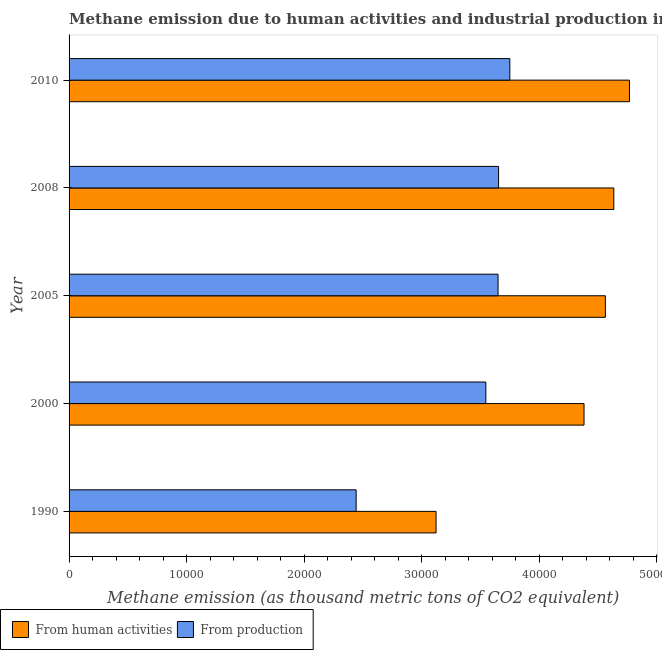Are the number of bars per tick equal to the number of legend labels?
Make the answer very short. Yes. How many bars are there on the 1st tick from the top?
Offer a terse response. 2. How many bars are there on the 3rd tick from the bottom?
Provide a succinct answer. 2. In how many cases, is the number of bars for a given year not equal to the number of legend labels?
Your answer should be very brief. 0. What is the amount of emissions generated from industries in 2000?
Provide a succinct answer. 3.54e+04. Across all years, what is the maximum amount of emissions from human activities?
Offer a terse response. 4.77e+04. Across all years, what is the minimum amount of emissions generated from industries?
Make the answer very short. 2.44e+04. In which year was the amount of emissions from human activities minimum?
Ensure brevity in your answer.  1990. What is the total amount of emissions from human activities in the graph?
Make the answer very short. 2.15e+05. What is the difference between the amount of emissions from human activities in 1990 and that in 2000?
Offer a terse response. -1.26e+04. What is the difference between the amount of emissions generated from industries in 2000 and the amount of emissions from human activities in 2010?
Make the answer very short. -1.22e+04. What is the average amount of emissions from human activities per year?
Your answer should be compact. 4.29e+04. In the year 1990, what is the difference between the amount of emissions from human activities and amount of emissions generated from industries?
Offer a terse response. 6797.8. In how many years, is the amount of emissions from human activities greater than 20000 thousand metric tons?
Give a very brief answer. 5. Is the amount of emissions generated from industries in 2000 less than that in 2008?
Provide a succinct answer. Yes. What is the difference between the highest and the second highest amount of emissions generated from industries?
Your response must be concise. 954.9. What is the difference between the highest and the lowest amount of emissions generated from industries?
Give a very brief answer. 1.31e+04. In how many years, is the amount of emissions generated from industries greater than the average amount of emissions generated from industries taken over all years?
Offer a terse response. 4. What does the 2nd bar from the top in 2010 represents?
Offer a terse response. From human activities. What does the 2nd bar from the bottom in 2005 represents?
Give a very brief answer. From production. How many bars are there?
Your answer should be compact. 10. Are all the bars in the graph horizontal?
Offer a very short reply. Yes. How many years are there in the graph?
Keep it short and to the point. 5. Are the values on the major ticks of X-axis written in scientific E-notation?
Offer a very short reply. No. Does the graph contain any zero values?
Your answer should be compact. No. Where does the legend appear in the graph?
Offer a very short reply. Bottom left. What is the title of the graph?
Keep it short and to the point. Methane emission due to human activities and industrial production in Algeria. What is the label or title of the X-axis?
Your answer should be compact. Methane emission (as thousand metric tons of CO2 equivalent). What is the Methane emission (as thousand metric tons of CO2 equivalent) of From human activities in 1990?
Give a very brief answer. 3.12e+04. What is the Methane emission (as thousand metric tons of CO2 equivalent) of From production in 1990?
Offer a very short reply. 2.44e+04. What is the Methane emission (as thousand metric tons of CO2 equivalent) in From human activities in 2000?
Give a very brief answer. 4.38e+04. What is the Methane emission (as thousand metric tons of CO2 equivalent) of From production in 2000?
Give a very brief answer. 3.54e+04. What is the Methane emission (as thousand metric tons of CO2 equivalent) of From human activities in 2005?
Your answer should be compact. 4.56e+04. What is the Methane emission (as thousand metric tons of CO2 equivalent) of From production in 2005?
Provide a succinct answer. 3.65e+04. What is the Methane emission (as thousand metric tons of CO2 equivalent) of From human activities in 2008?
Provide a succinct answer. 4.63e+04. What is the Methane emission (as thousand metric tons of CO2 equivalent) in From production in 2008?
Provide a succinct answer. 3.65e+04. What is the Methane emission (as thousand metric tons of CO2 equivalent) in From human activities in 2010?
Make the answer very short. 4.77e+04. What is the Methane emission (as thousand metric tons of CO2 equivalent) in From production in 2010?
Make the answer very short. 3.75e+04. Across all years, what is the maximum Methane emission (as thousand metric tons of CO2 equivalent) in From human activities?
Offer a terse response. 4.77e+04. Across all years, what is the maximum Methane emission (as thousand metric tons of CO2 equivalent) in From production?
Make the answer very short. 3.75e+04. Across all years, what is the minimum Methane emission (as thousand metric tons of CO2 equivalent) of From human activities?
Your answer should be very brief. 3.12e+04. Across all years, what is the minimum Methane emission (as thousand metric tons of CO2 equivalent) in From production?
Your response must be concise. 2.44e+04. What is the total Methane emission (as thousand metric tons of CO2 equivalent) of From human activities in the graph?
Keep it short and to the point. 2.15e+05. What is the total Methane emission (as thousand metric tons of CO2 equivalent) in From production in the graph?
Keep it short and to the point. 1.70e+05. What is the difference between the Methane emission (as thousand metric tons of CO2 equivalent) of From human activities in 1990 and that in 2000?
Offer a very short reply. -1.26e+04. What is the difference between the Methane emission (as thousand metric tons of CO2 equivalent) of From production in 1990 and that in 2000?
Ensure brevity in your answer.  -1.10e+04. What is the difference between the Methane emission (as thousand metric tons of CO2 equivalent) in From human activities in 1990 and that in 2005?
Provide a succinct answer. -1.44e+04. What is the difference between the Methane emission (as thousand metric tons of CO2 equivalent) of From production in 1990 and that in 2005?
Provide a short and direct response. -1.21e+04. What is the difference between the Methane emission (as thousand metric tons of CO2 equivalent) in From human activities in 1990 and that in 2008?
Your answer should be compact. -1.51e+04. What is the difference between the Methane emission (as thousand metric tons of CO2 equivalent) of From production in 1990 and that in 2008?
Provide a short and direct response. -1.21e+04. What is the difference between the Methane emission (as thousand metric tons of CO2 equivalent) in From human activities in 1990 and that in 2010?
Your response must be concise. -1.64e+04. What is the difference between the Methane emission (as thousand metric tons of CO2 equivalent) in From production in 1990 and that in 2010?
Keep it short and to the point. -1.31e+04. What is the difference between the Methane emission (as thousand metric tons of CO2 equivalent) of From human activities in 2000 and that in 2005?
Offer a very short reply. -1815.4. What is the difference between the Methane emission (as thousand metric tons of CO2 equivalent) of From production in 2000 and that in 2005?
Give a very brief answer. -1037.5. What is the difference between the Methane emission (as thousand metric tons of CO2 equivalent) in From human activities in 2000 and that in 2008?
Offer a terse response. -2532.2. What is the difference between the Methane emission (as thousand metric tons of CO2 equivalent) of From production in 2000 and that in 2008?
Keep it short and to the point. -1082.4. What is the difference between the Methane emission (as thousand metric tons of CO2 equivalent) in From human activities in 2000 and that in 2010?
Provide a short and direct response. -3865.2. What is the difference between the Methane emission (as thousand metric tons of CO2 equivalent) in From production in 2000 and that in 2010?
Provide a short and direct response. -2037.3. What is the difference between the Methane emission (as thousand metric tons of CO2 equivalent) in From human activities in 2005 and that in 2008?
Provide a succinct answer. -716.8. What is the difference between the Methane emission (as thousand metric tons of CO2 equivalent) in From production in 2005 and that in 2008?
Give a very brief answer. -44.9. What is the difference between the Methane emission (as thousand metric tons of CO2 equivalent) of From human activities in 2005 and that in 2010?
Your answer should be compact. -2049.8. What is the difference between the Methane emission (as thousand metric tons of CO2 equivalent) of From production in 2005 and that in 2010?
Offer a very short reply. -999.8. What is the difference between the Methane emission (as thousand metric tons of CO2 equivalent) in From human activities in 2008 and that in 2010?
Ensure brevity in your answer.  -1333. What is the difference between the Methane emission (as thousand metric tons of CO2 equivalent) of From production in 2008 and that in 2010?
Give a very brief answer. -954.9. What is the difference between the Methane emission (as thousand metric tons of CO2 equivalent) of From human activities in 1990 and the Methane emission (as thousand metric tons of CO2 equivalent) of From production in 2000?
Your answer should be compact. -4234.8. What is the difference between the Methane emission (as thousand metric tons of CO2 equivalent) of From human activities in 1990 and the Methane emission (as thousand metric tons of CO2 equivalent) of From production in 2005?
Offer a terse response. -5272.3. What is the difference between the Methane emission (as thousand metric tons of CO2 equivalent) in From human activities in 1990 and the Methane emission (as thousand metric tons of CO2 equivalent) in From production in 2008?
Your answer should be very brief. -5317.2. What is the difference between the Methane emission (as thousand metric tons of CO2 equivalent) of From human activities in 1990 and the Methane emission (as thousand metric tons of CO2 equivalent) of From production in 2010?
Provide a short and direct response. -6272.1. What is the difference between the Methane emission (as thousand metric tons of CO2 equivalent) of From human activities in 2000 and the Methane emission (as thousand metric tons of CO2 equivalent) of From production in 2005?
Ensure brevity in your answer.  7311.7. What is the difference between the Methane emission (as thousand metric tons of CO2 equivalent) of From human activities in 2000 and the Methane emission (as thousand metric tons of CO2 equivalent) of From production in 2008?
Keep it short and to the point. 7266.8. What is the difference between the Methane emission (as thousand metric tons of CO2 equivalent) in From human activities in 2000 and the Methane emission (as thousand metric tons of CO2 equivalent) in From production in 2010?
Keep it short and to the point. 6311.9. What is the difference between the Methane emission (as thousand metric tons of CO2 equivalent) in From human activities in 2005 and the Methane emission (as thousand metric tons of CO2 equivalent) in From production in 2008?
Ensure brevity in your answer.  9082.2. What is the difference between the Methane emission (as thousand metric tons of CO2 equivalent) of From human activities in 2005 and the Methane emission (as thousand metric tons of CO2 equivalent) of From production in 2010?
Offer a terse response. 8127.3. What is the difference between the Methane emission (as thousand metric tons of CO2 equivalent) of From human activities in 2008 and the Methane emission (as thousand metric tons of CO2 equivalent) of From production in 2010?
Offer a very short reply. 8844.1. What is the average Methane emission (as thousand metric tons of CO2 equivalent) of From human activities per year?
Offer a terse response. 4.29e+04. What is the average Methane emission (as thousand metric tons of CO2 equivalent) of From production per year?
Your response must be concise. 3.41e+04. In the year 1990, what is the difference between the Methane emission (as thousand metric tons of CO2 equivalent) of From human activities and Methane emission (as thousand metric tons of CO2 equivalent) of From production?
Ensure brevity in your answer.  6797.8. In the year 2000, what is the difference between the Methane emission (as thousand metric tons of CO2 equivalent) of From human activities and Methane emission (as thousand metric tons of CO2 equivalent) of From production?
Provide a succinct answer. 8349.2. In the year 2005, what is the difference between the Methane emission (as thousand metric tons of CO2 equivalent) in From human activities and Methane emission (as thousand metric tons of CO2 equivalent) in From production?
Offer a terse response. 9127.1. In the year 2008, what is the difference between the Methane emission (as thousand metric tons of CO2 equivalent) of From human activities and Methane emission (as thousand metric tons of CO2 equivalent) of From production?
Offer a terse response. 9799. In the year 2010, what is the difference between the Methane emission (as thousand metric tons of CO2 equivalent) in From human activities and Methane emission (as thousand metric tons of CO2 equivalent) in From production?
Offer a terse response. 1.02e+04. What is the ratio of the Methane emission (as thousand metric tons of CO2 equivalent) in From human activities in 1990 to that in 2000?
Provide a short and direct response. 0.71. What is the ratio of the Methane emission (as thousand metric tons of CO2 equivalent) of From production in 1990 to that in 2000?
Ensure brevity in your answer.  0.69. What is the ratio of the Methane emission (as thousand metric tons of CO2 equivalent) of From human activities in 1990 to that in 2005?
Ensure brevity in your answer.  0.68. What is the ratio of the Methane emission (as thousand metric tons of CO2 equivalent) of From production in 1990 to that in 2005?
Make the answer very short. 0.67. What is the ratio of the Methane emission (as thousand metric tons of CO2 equivalent) in From human activities in 1990 to that in 2008?
Your answer should be compact. 0.67. What is the ratio of the Methane emission (as thousand metric tons of CO2 equivalent) in From production in 1990 to that in 2008?
Offer a terse response. 0.67. What is the ratio of the Methane emission (as thousand metric tons of CO2 equivalent) in From human activities in 1990 to that in 2010?
Your response must be concise. 0.65. What is the ratio of the Methane emission (as thousand metric tons of CO2 equivalent) of From production in 1990 to that in 2010?
Give a very brief answer. 0.65. What is the ratio of the Methane emission (as thousand metric tons of CO2 equivalent) in From human activities in 2000 to that in 2005?
Your answer should be very brief. 0.96. What is the ratio of the Methane emission (as thousand metric tons of CO2 equivalent) in From production in 2000 to that in 2005?
Your response must be concise. 0.97. What is the ratio of the Methane emission (as thousand metric tons of CO2 equivalent) in From human activities in 2000 to that in 2008?
Give a very brief answer. 0.95. What is the ratio of the Methane emission (as thousand metric tons of CO2 equivalent) in From production in 2000 to that in 2008?
Provide a short and direct response. 0.97. What is the ratio of the Methane emission (as thousand metric tons of CO2 equivalent) of From human activities in 2000 to that in 2010?
Your response must be concise. 0.92. What is the ratio of the Methane emission (as thousand metric tons of CO2 equivalent) in From production in 2000 to that in 2010?
Give a very brief answer. 0.95. What is the ratio of the Methane emission (as thousand metric tons of CO2 equivalent) in From human activities in 2005 to that in 2008?
Provide a short and direct response. 0.98. What is the ratio of the Methane emission (as thousand metric tons of CO2 equivalent) of From production in 2005 to that in 2008?
Your response must be concise. 1. What is the ratio of the Methane emission (as thousand metric tons of CO2 equivalent) in From human activities in 2005 to that in 2010?
Give a very brief answer. 0.96. What is the ratio of the Methane emission (as thousand metric tons of CO2 equivalent) in From production in 2005 to that in 2010?
Offer a terse response. 0.97. What is the ratio of the Methane emission (as thousand metric tons of CO2 equivalent) of From production in 2008 to that in 2010?
Your answer should be very brief. 0.97. What is the difference between the highest and the second highest Methane emission (as thousand metric tons of CO2 equivalent) of From human activities?
Give a very brief answer. 1333. What is the difference between the highest and the second highest Methane emission (as thousand metric tons of CO2 equivalent) in From production?
Ensure brevity in your answer.  954.9. What is the difference between the highest and the lowest Methane emission (as thousand metric tons of CO2 equivalent) in From human activities?
Ensure brevity in your answer.  1.64e+04. What is the difference between the highest and the lowest Methane emission (as thousand metric tons of CO2 equivalent) in From production?
Your response must be concise. 1.31e+04. 